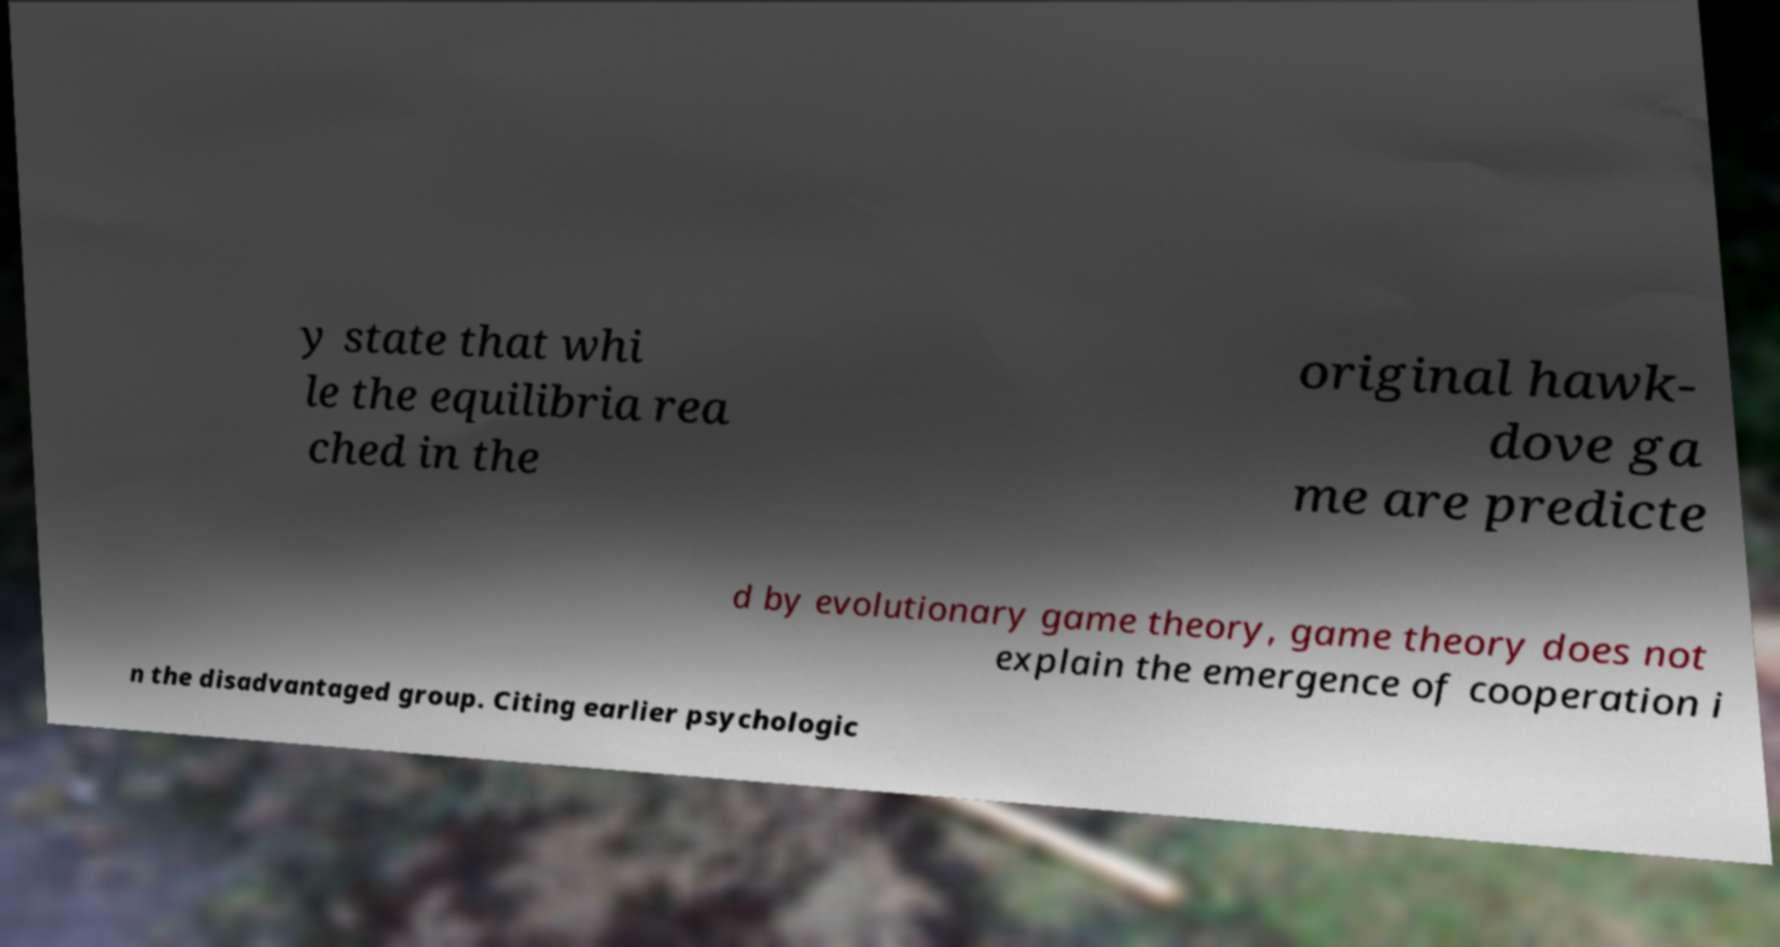Could you extract and type out the text from this image? y state that whi le the equilibria rea ched in the original hawk- dove ga me are predicte d by evolutionary game theory, game theory does not explain the emergence of cooperation i n the disadvantaged group. Citing earlier psychologic 